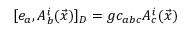Convert formula to latex. <formula><loc_0><loc_0><loc_500><loc_500>[ e _ { a } , A _ { b } ^ { i } ( \vec { x } ) ] _ { D } = g c _ { a b c } A _ { c } ^ { i } ( \vec { x } )</formula> 